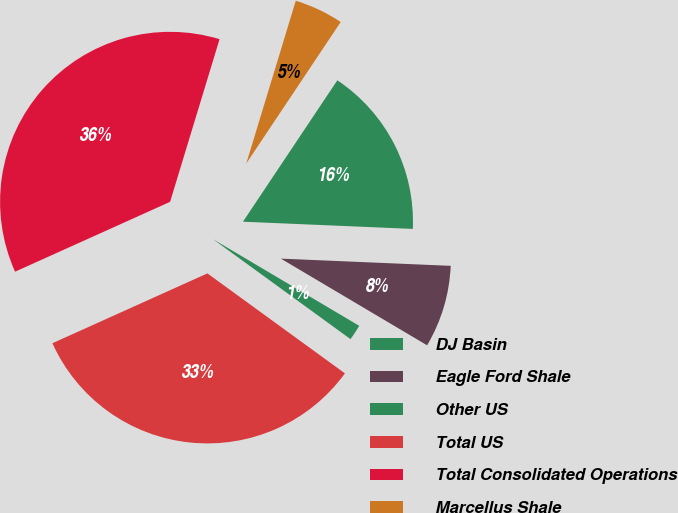Convert chart. <chart><loc_0><loc_0><loc_500><loc_500><pie_chart><fcel>DJ Basin<fcel>Eagle Ford Shale<fcel>Other US<fcel>Total US<fcel>Total Consolidated Operations<fcel>Marcellus Shale<nl><fcel>16.31%<fcel>7.84%<fcel>1.49%<fcel>33.26%<fcel>36.44%<fcel>4.67%<nl></chart> 